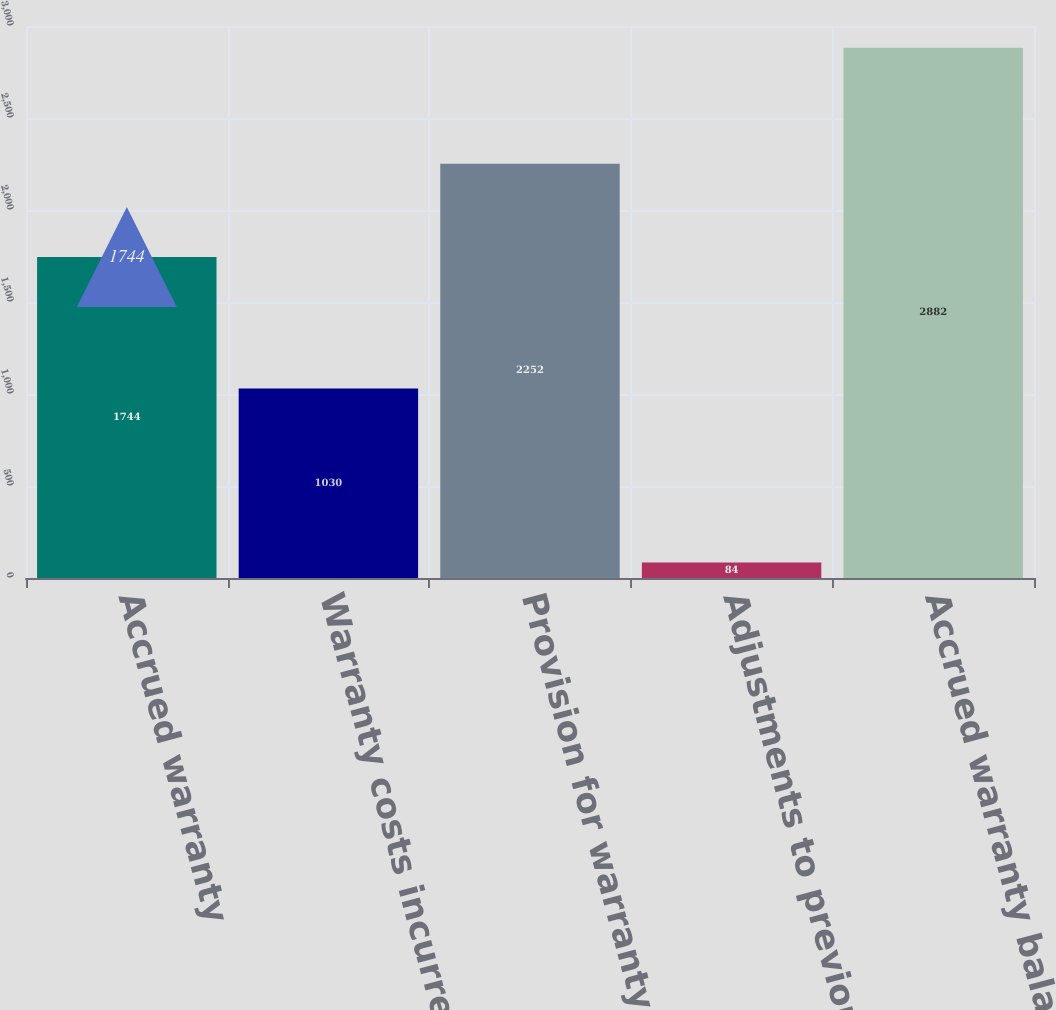<chart> <loc_0><loc_0><loc_500><loc_500><bar_chart><fcel>Accrued warranty<fcel>Warranty costs incurred<fcel>Provision for warranty<fcel>Adjustments to previous<fcel>Accrued warranty balance-end<nl><fcel>1744<fcel>1030<fcel>2252<fcel>84<fcel>2882<nl></chart> 